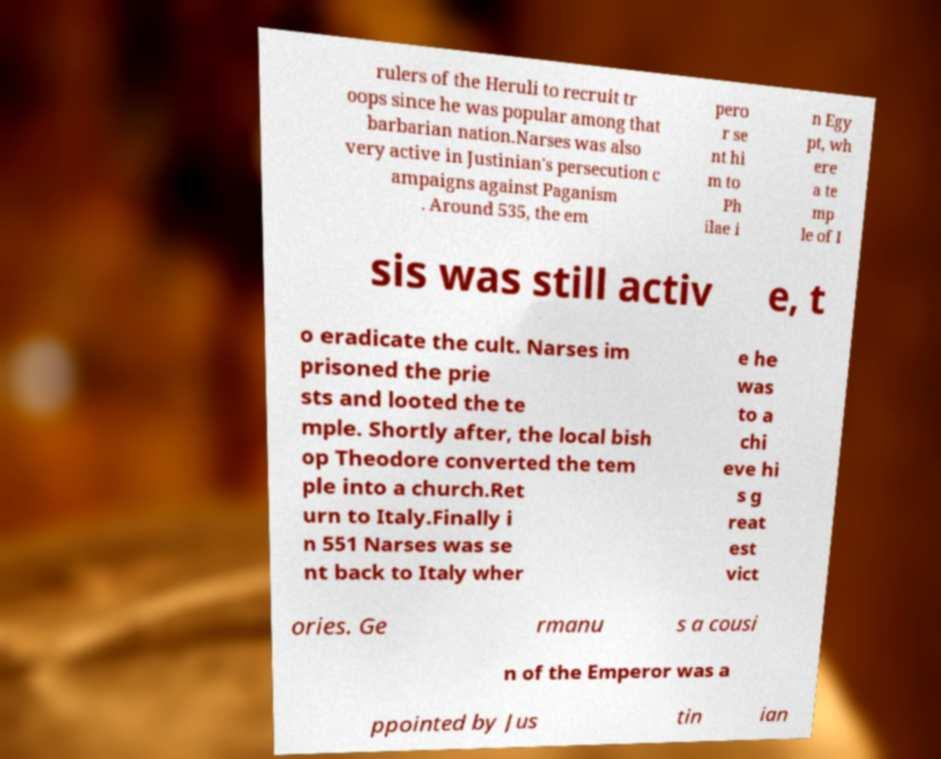Can you accurately transcribe the text from the provided image for me? rulers of the Heruli to recruit tr oops since he was popular among that barbarian nation.Narses was also very active in Justinian's persecution c ampaigns against Paganism . Around 535, the em pero r se nt hi m to Ph ilae i n Egy pt, wh ere a te mp le of I sis was still activ e, t o eradicate the cult. Narses im prisoned the prie sts and looted the te mple. Shortly after, the local bish op Theodore converted the tem ple into a church.Ret urn to Italy.Finally i n 551 Narses was se nt back to Italy wher e he was to a chi eve hi s g reat est vict ories. Ge rmanu s a cousi n of the Emperor was a ppointed by Jus tin ian 